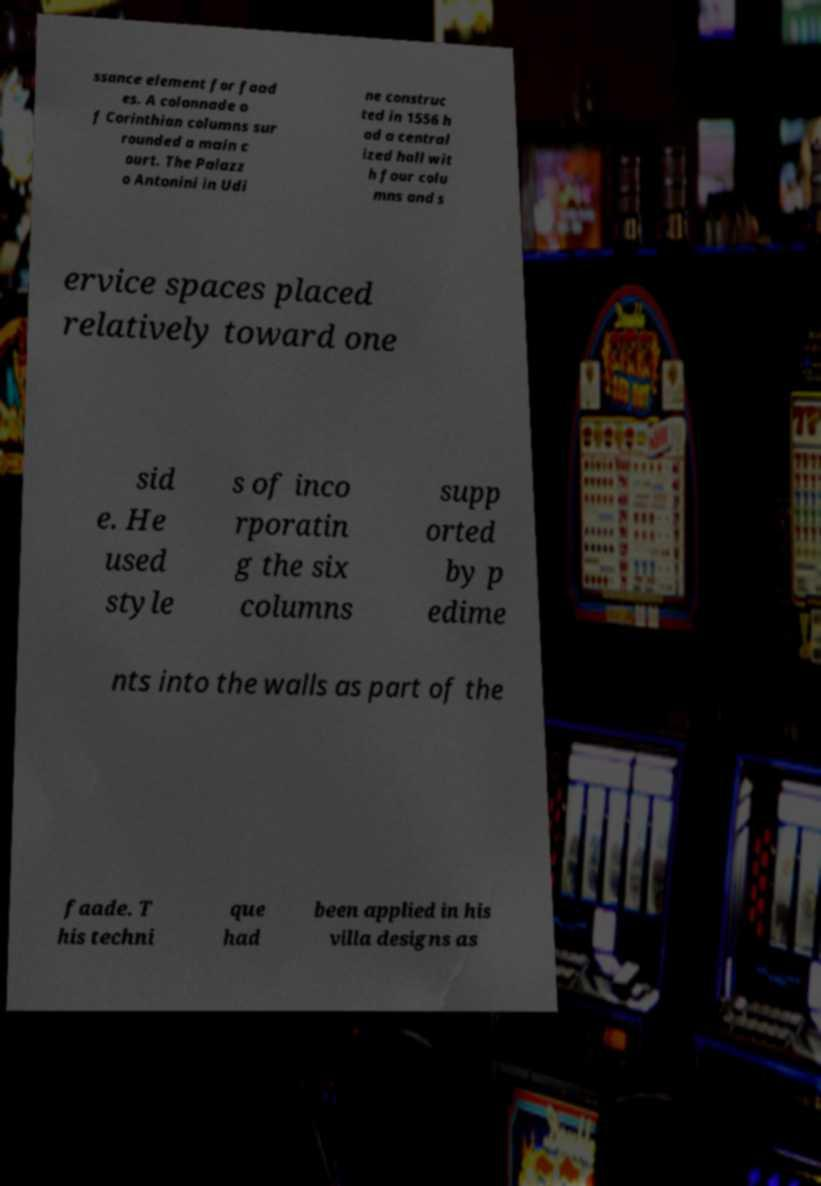Can you accurately transcribe the text from the provided image for me? ssance element for faad es. A colonnade o f Corinthian columns sur rounded a main c ourt. The Palazz o Antonini in Udi ne construc ted in 1556 h ad a central ized hall wit h four colu mns and s ervice spaces placed relatively toward one sid e. He used style s of inco rporatin g the six columns supp orted by p edime nts into the walls as part of the faade. T his techni que had been applied in his villa designs as 